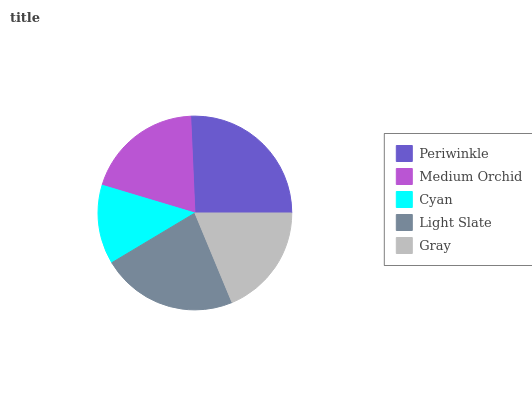Is Cyan the minimum?
Answer yes or no. Yes. Is Periwinkle the maximum?
Answer yes or no. Yes. Is Medium Orchid the minimum?
Answer yes or no. No. Is Medium Orchid the maximum?
Answer yes or no. No. Is Periwinkle greater than Medium Orchid?
Answer yes or no. Yes. Is Medium Orchid less than Periwinkle?
Answer yes or no. Yes. Is Medium Orchid greater than Periwinkle?
Answer yes or no. No. Is Periwinkle less than Medium Orchid?
Answer yes or no. No. Is Medium Orchid the high median?
Answer yes or no. Yes. Is Medium Orchid the low median?
Answer yes or no. Yes. Is Periwinkle the high median?
Answer yes or no. No. Is Periwinkle the low median?
Answer yes or no. No. 